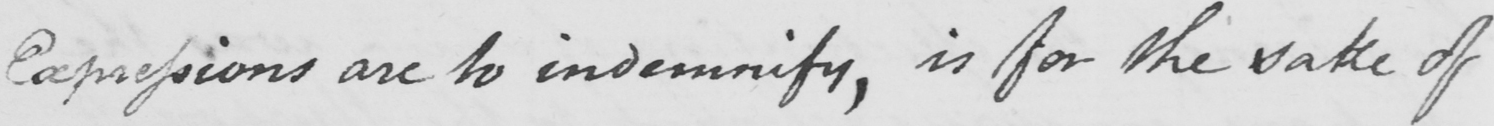What text is written in this handwritten line? Expressions are to indemnity , is for the sake of 